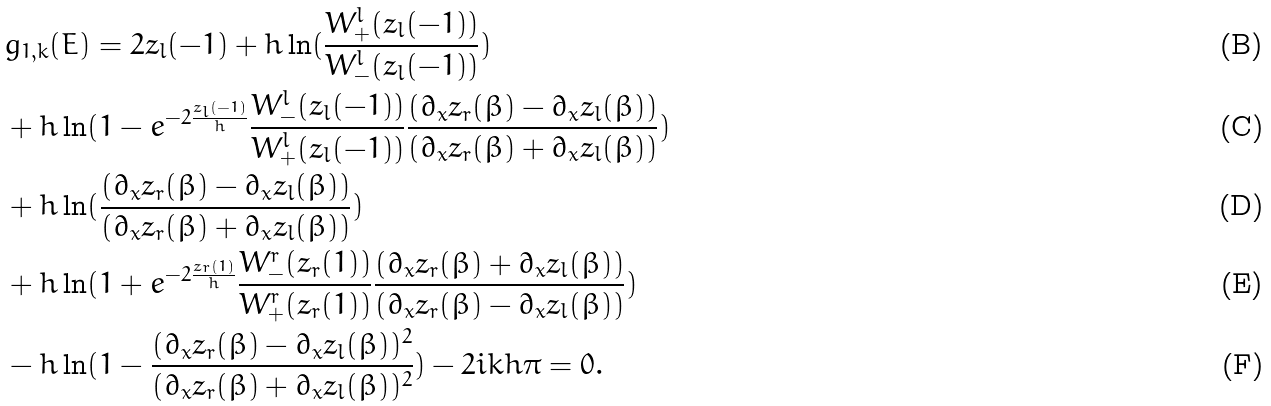Convert formula to latex. <formula><loc_0><loc_0><loc_500><loc_500>& g _ { 1 , k } ( E ) = 2 z _ { l } ( - 1 ) + h \ln ( \frac { W ^ { l } _ { + } ( z _ { l } ( - 1 ) ) } { W ^ { l } _ { - } ( z _ { l } ( - 1 ) ) } ) \\ & + h \ln ( 1 - e ^ { - 2 \frac { z _ { l } ( - 1 ) } h } \frac { W ^ { l } _ { - } ( z _ { l } ( - 1 ) ) } { W ^ { l } _ { + } ( z _ { l } ( - 1 ) ) } \frac { ( \partial _ { x } z _ { r } ( \beta ) - \partial _ { x } z _ { l } ( \beta ) ) } { ( \partial _ { x } z _ { r } ( \beta ) + \partial _ { x } z _ { l } ( \beta ) ) } ) \\ & + h \ln ( \frac { ( \partial _ { x } z _ { r } ( \beta ) - \partial _ { x } z _ { l } ( \beta ) ) } { ( \partial _ { x } z _ { r } ( \beta ) + \partial _ { x } z _ { l } ( \beta ) ) } ) \\ & + h \ln ( 1 + e ^ { - 2 \frac { z _ { r } ( 1 ) } h } \frac { W ^ { r } _ { - } ( z _ { r } ( 1 ) ) } { W ^ { r } _ { + } ( z _ { r } ( 1 ) ) } \frac { ( \partial _ { x } z _ { r } ( \beta ) + \partial _ { x } z _ { l } ( \beta ) ) } { ( \partial _ { x } z _ { r } ( \beta ) - \partial _ { x } z _ { l } ( \beta ) ) } ) \\ & - h \ln ( 1 - \frac { ( \partial _ { x } z _ { r } ( \beta ) - \partial _ { x } z _ { l } ( \beta ) ) ^ { 2 } } { ( \partial _ { x } z _ { r } ( \beta ) + \partial _ { x } z _ { l } ( \beta ) ) ^ { 2 } } ) - 2 i k h \pi = 0 .</formula> 